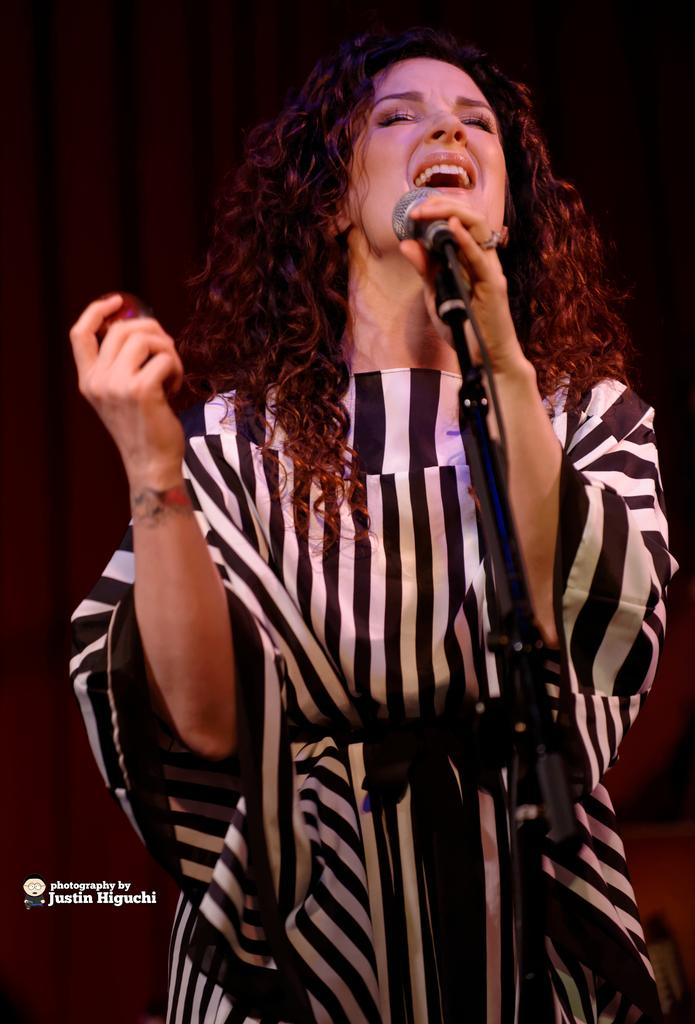Who is the main subject in the image? There is a woman in the image. What is the woman wearing? The woman is wearing a white and black dress. What is the woman holding in the image? The woman is holding a microphone. What is the woman doing in the image? The woman is singing. What type of books can be seen in the image? There are no books present in the image. What is the woman protesting in the image? There is no protest depicted in the image; the woman is singing. 